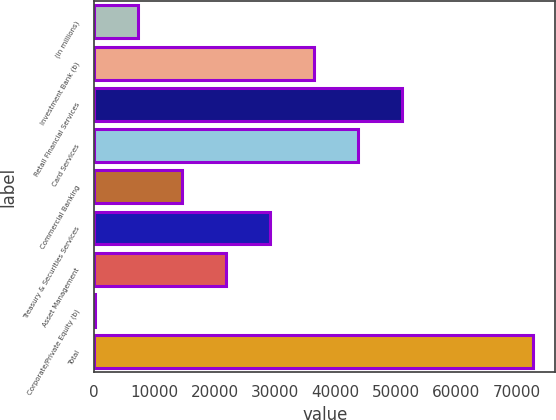<chart> <loc_0><loc_0><loc_500><loc_500><bar_chart><fcel>(in millions)<fcel>Investment Bank (b)<fcel>Retail Financial Services<fcel>Card Services<fcel>Commercial Banking<fcel>Treasury & Securities Services<fcel>Asset Management<fcel>Corporate/Private Equity (b)<fcel>Total<nl><fcel>7324<fcel>36412<fcel>50956<fcel>43684<fcel>14596<fcel>29140<fcel>21868<fcel>52<fcel>72772<nl></chart> 